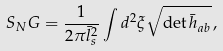<formula> <loc_0><loc_0><loc_500><loc_500>S _ { N } G = \frac { 1 } { 2 \pi \bar { l } _ { s } ^ { 2 } } \int d ^ { 2 } \xi \sqrt { \det \bar { h } _ { a b } } \, ,</formula> 